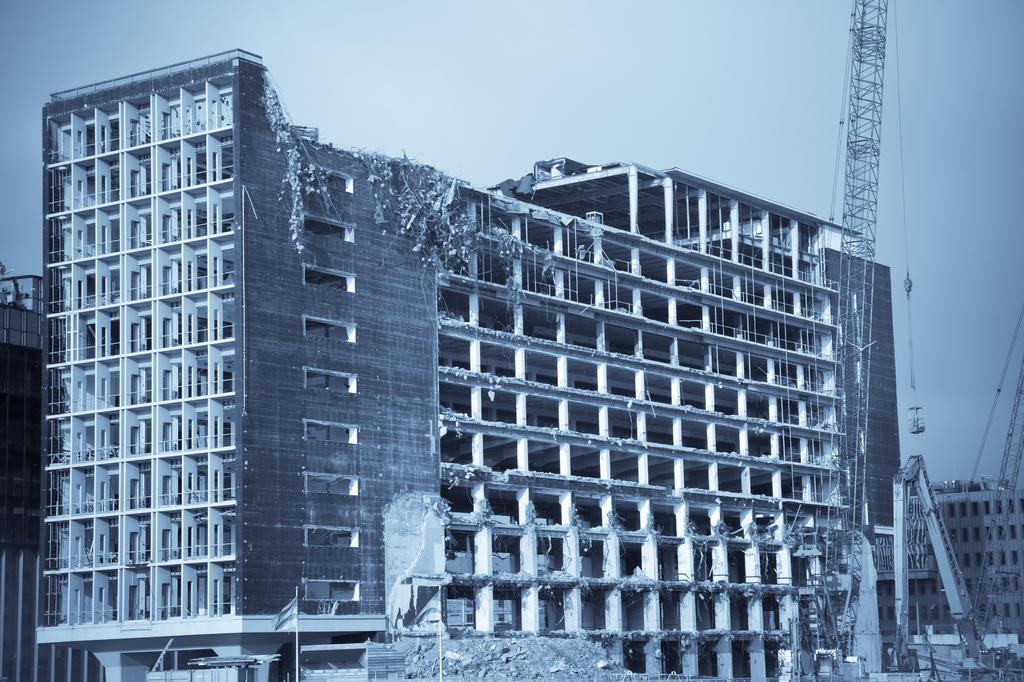Could you give a brief overview of what you see in this image? In this image I see buildings and I see the rods over here and I see a vehicle over here and I see the 2 flags. In the background I see the sky. 